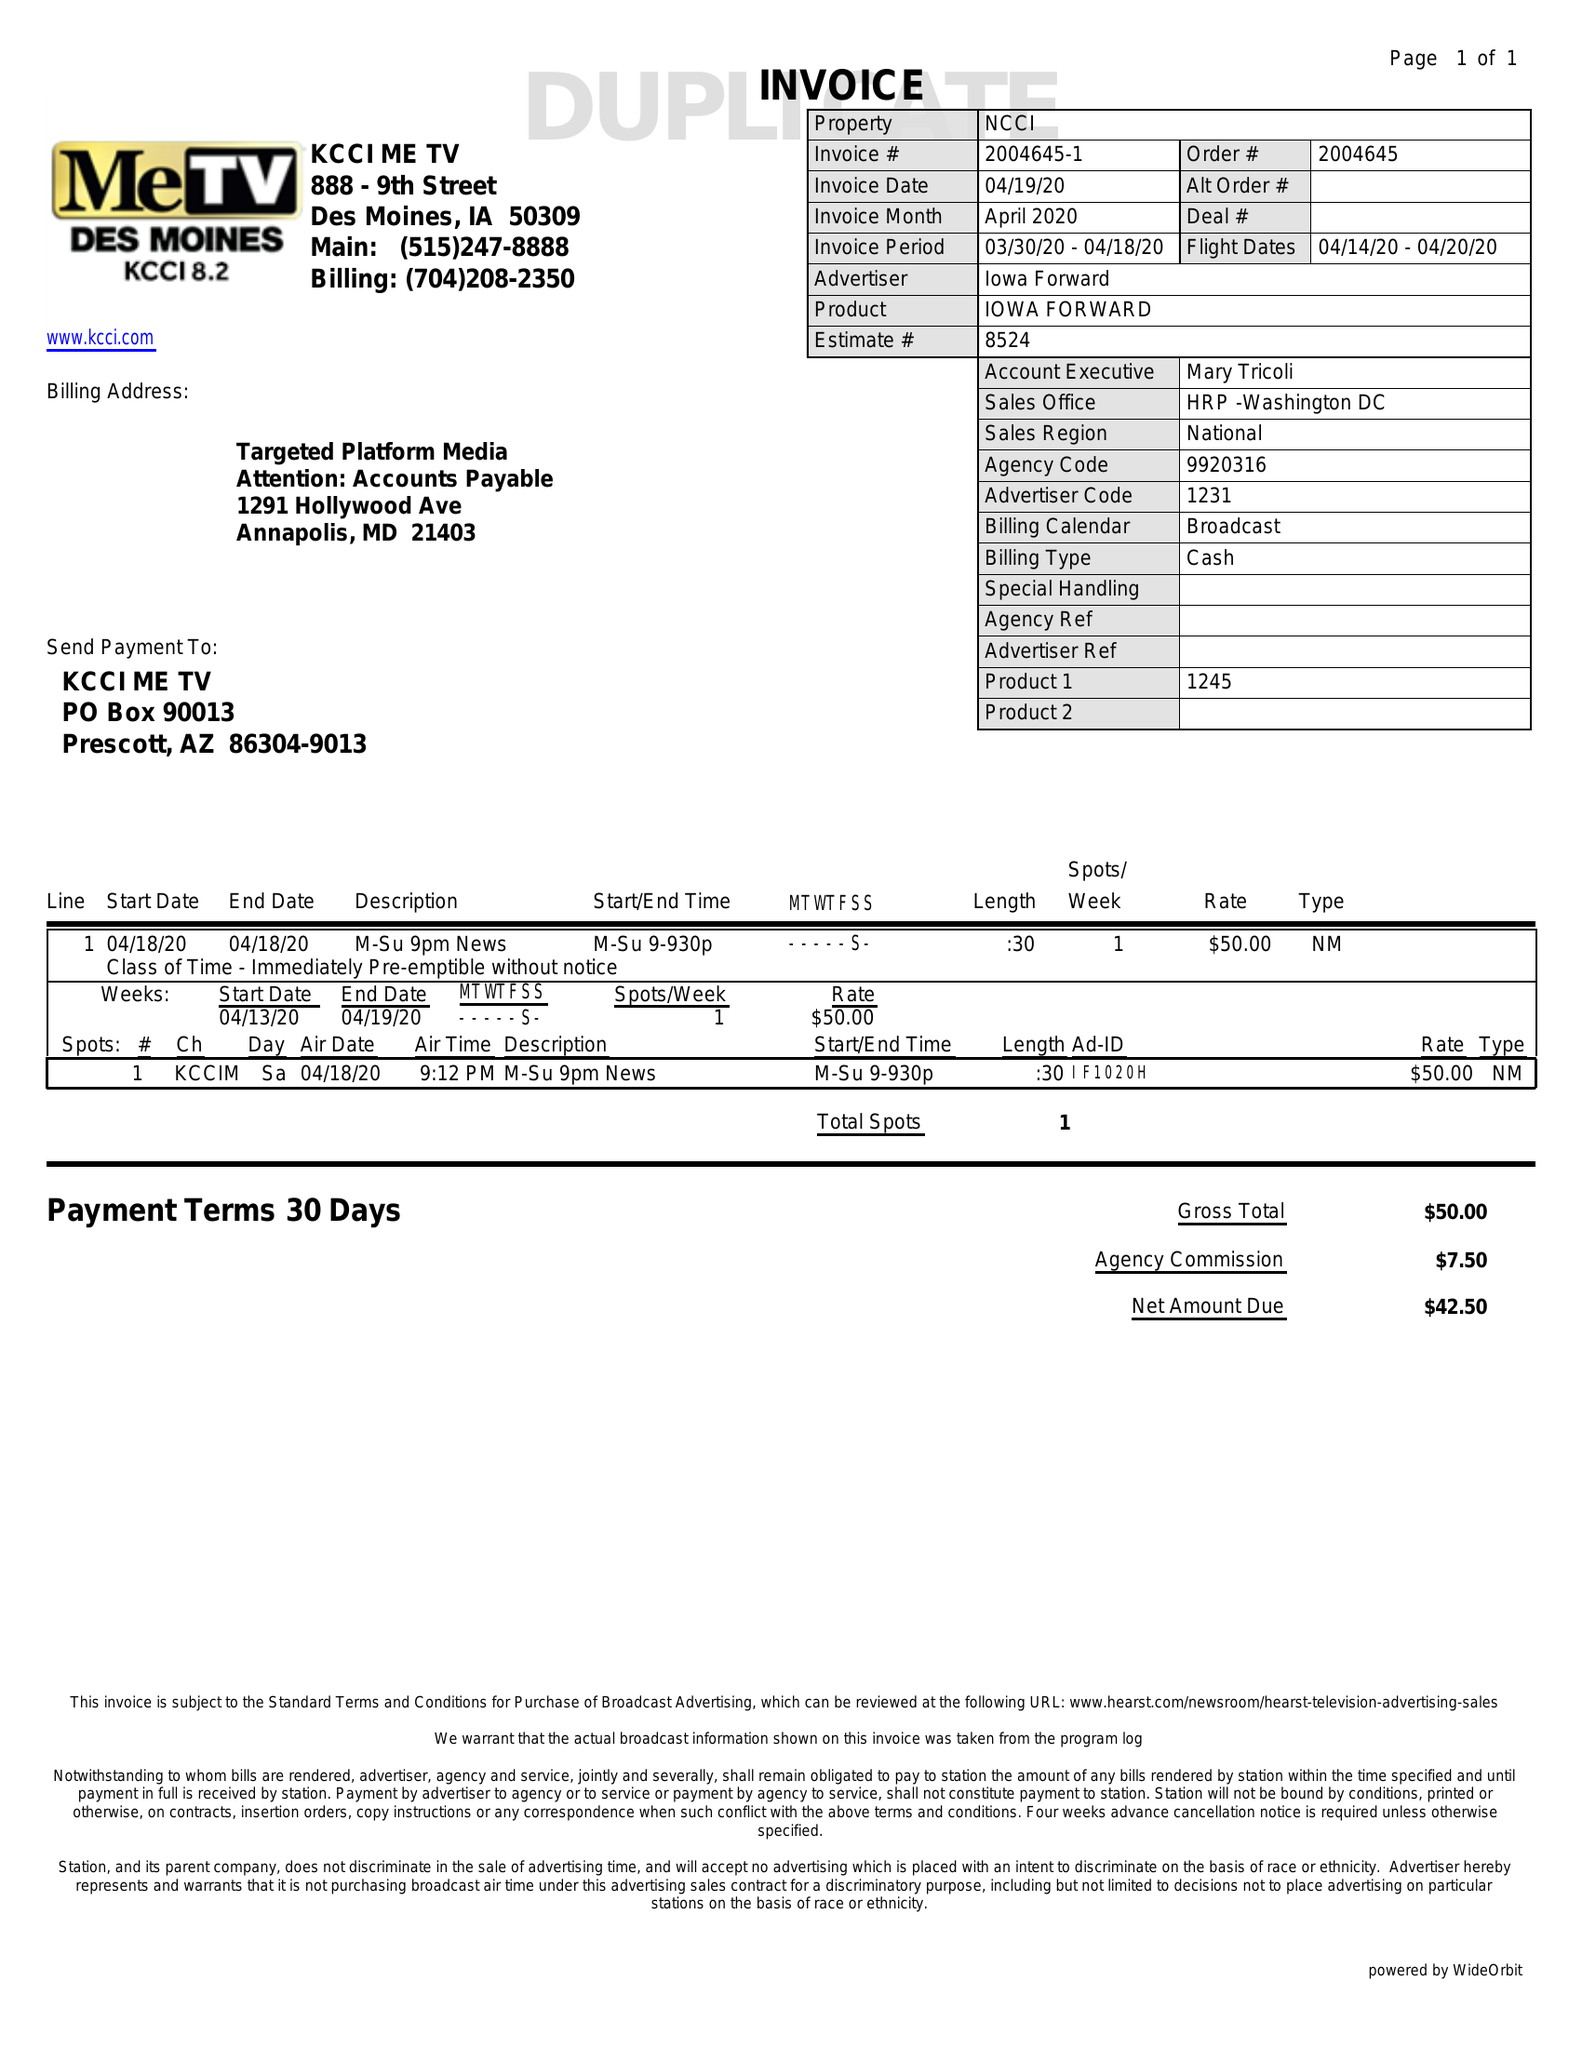What is the value for the contract_num?
Answer the question using a single word or phrase. 2004645 